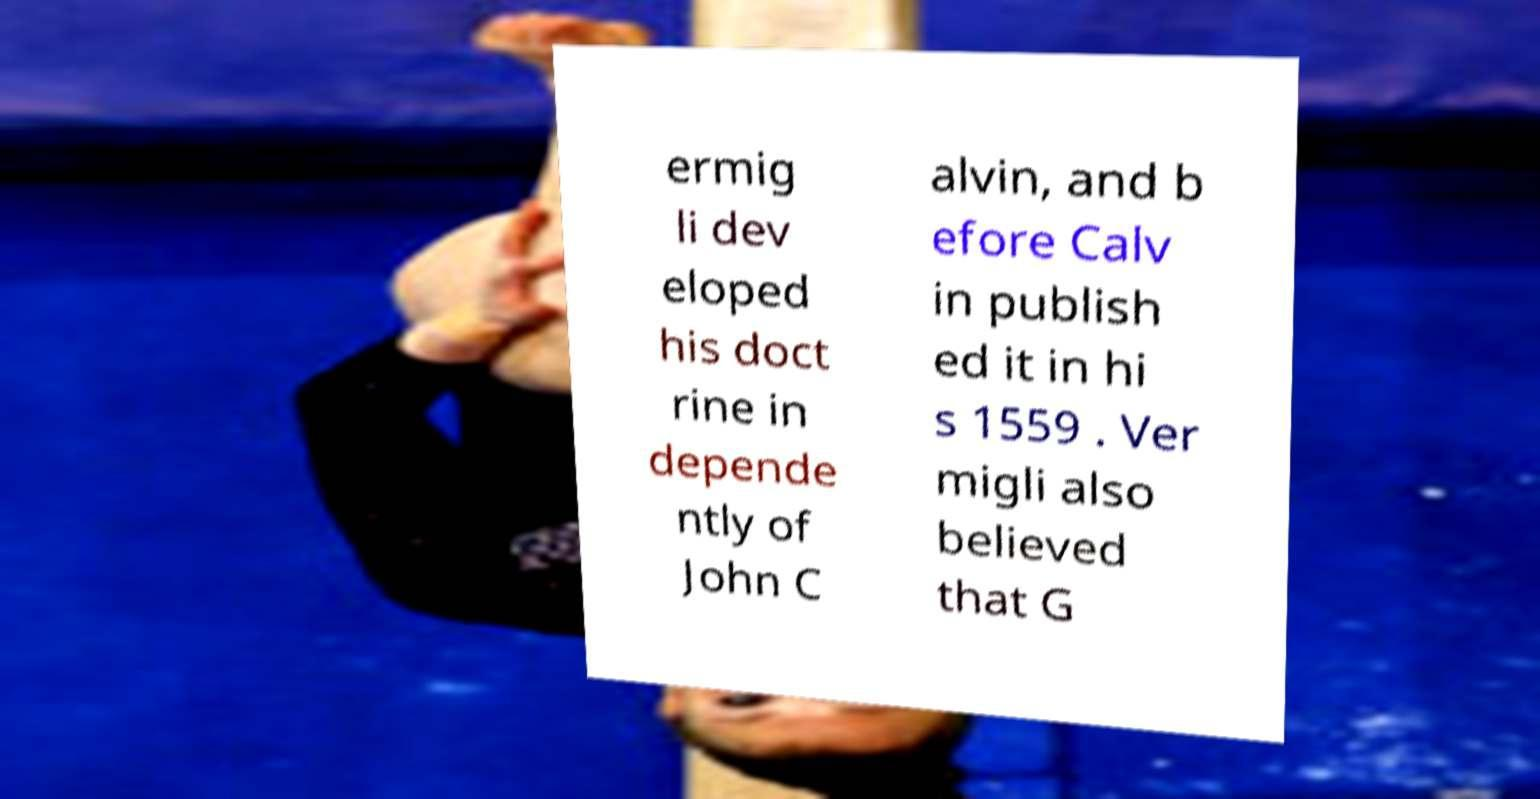Can you accurately transcribe the text from the provided image for me? ermig li dev eloped his doct rine in depende ntly of John C alvin, and b efore Calv in publish ed it in hi s 1559 . Ver migli also believed that G 